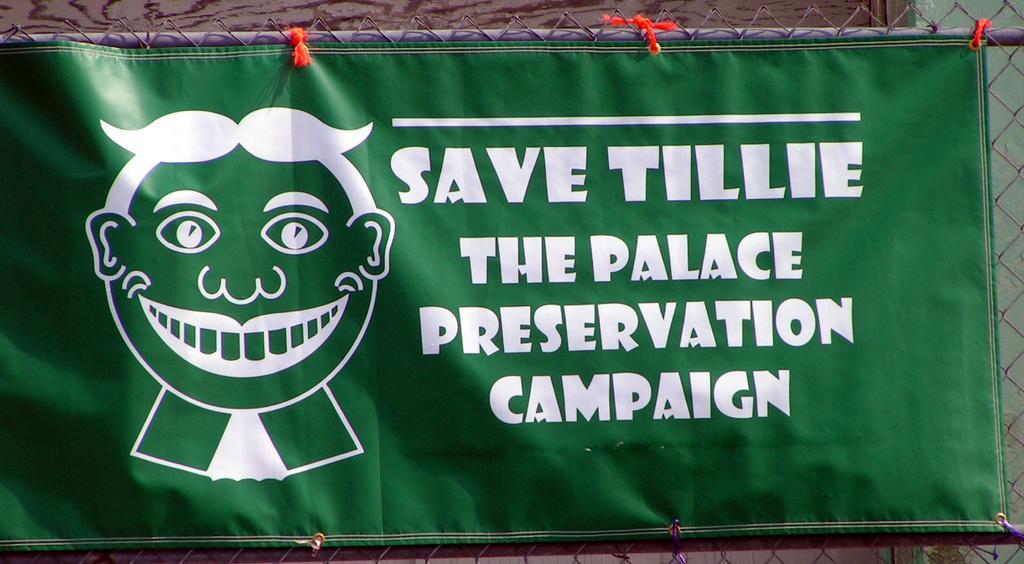Could you give a brief overview of what you see in this image? In the foreground of the picture, there is a banner with some text is on a fencing. 